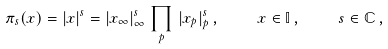Convert formula to latex. <formula><loc_0><loc_0><loc_500><loc_500>\pi _ { s } ( x ) = | x | ^ { s } = | x _ { \infty } | _ { \infty } ^ { s } \, \prod _ { p } \, | x _ { p } | _ { p } ^ { s } \, , \quad x \in { \mathbb { I } } \, , \quad s \in { \mathbb { C } } \, ,</formula> 